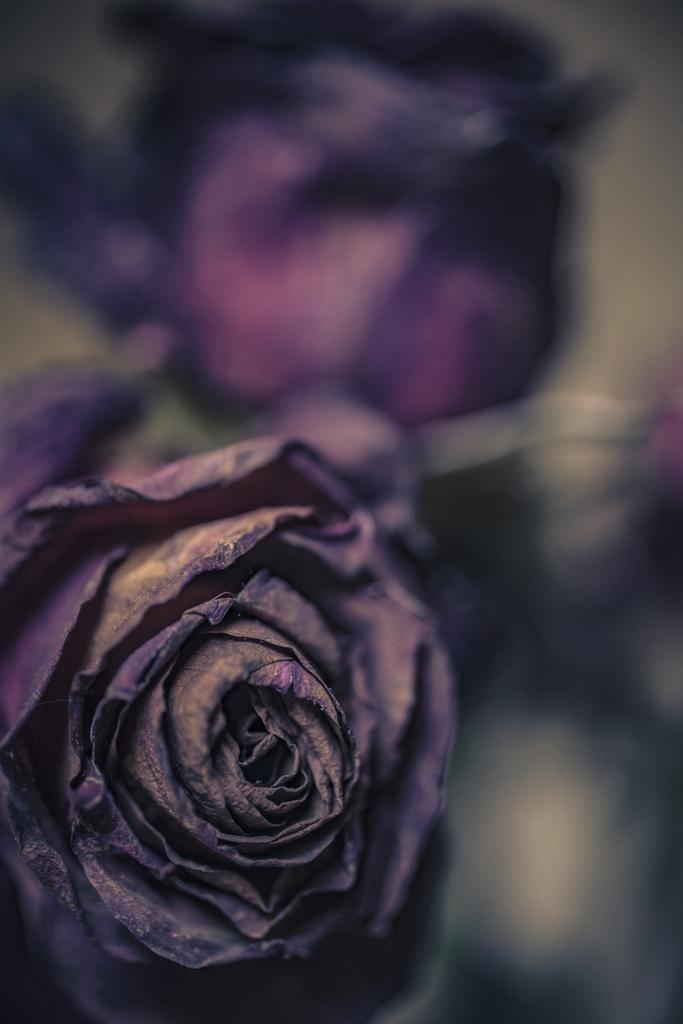How would you summarize this image in a sentence or two? In this image we can see there is a flower and at the back it looks like a blur. 